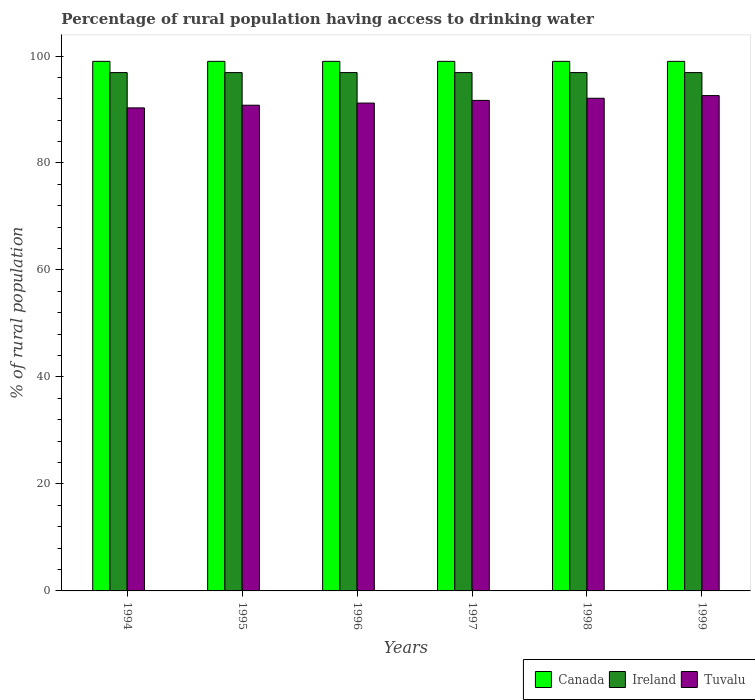How many groups of bars are there?
Offer a terse response. 6. How many bars are there on the 6th tick from the left?
Give a very brief answer. 3. What is the percentage of rural population having access to drinking water in Tuvalu in 1996?
Your answer should be very brief. 91.2. Across all years, what is the maximum percentage of rural population having access to drinking water in Ireland?
Ensure brevity in your answer.  96.9. Across all years, what is the minimum percentage of rural population having access to drinking water in Canada?
Keep it short and to the point. 99. In which year was the percentage of rural population having access to drinking water in Ireland maximum?
Your response must be concise. 1994. What is the total percentage of rural population having access to drinking water in Ireland in the graph?
Offer a very short reply. 581.4. What is the difference between the percentage of rural population having access to drinking water in Tuvalu in 1995 and that in 1997?
Your answer should be very brief. -0.9. What is the difference between the percentage of rural population having access to drinking water in Tuvalu in 1999 and the percentage of rural population having access to drinking water in Canada in 1995?
Offer a terse response. -6.4. In the year 1998, what is the difference between the percentage of rural population having access to drinking water in Tuvalu and percentage of rural population having access to drinking water in Ireland?
Provide a succinct answer. -4.8. In how many years, is the percentage of rural population having access to drinking water in Ireland greater than 48 %?
Your answer should be compact. 6. What is the ratio of the percentage of rural population having access to drinking water in Tuvalu in 1994 to that in 1999?
Ensure brevity in your answer.  0.98. What is the difference between the highest and the lowest percentage of rural population having access to drinking water in Tuvalu?
Your answer should be compact. 2.3. In how many years, is the percentage of rural population having access to drinking water in Ireland greater than the average percentage of rural population having access to drinking water in Ireland taken over all years?
Your answer should be very brief. 6. What does the 3rd bar from the left in 1994 represents?
Provide a short and direct response. Tuvalu. What does the 2nd bar from the right in 1994 represents?
Provide a succinct answer. Ireland. Is it the case that in every year, the sum of the percentage of rural population having access to drinking water in Tuvalu and percentage of rural population having access to drinking water in Ireland is greater than the percentage of rural population having access to drinking water in Canada?
Offer a very short reply. Yes. How many bars are there?
Offer a terse response. 18. Are all the bars in the graph horizontal?
Keep it short and to the point. No. What is the difference between two consecutive major ticks on the Y-axis?
Your answer should be compact. 20. Where does the legend appear in the graph?
Keep it short and to the point. Bottom right. How many legend labels are there?
Offer a terse response. 3. How are the legend labels stacked?
Keep it short and to the point. Horizontal. What is the title of the graph?
Your answer should be very brief. Percentage of rural population having access to drinking water. What is the label or title of the Y-axis?
Your response must be concise. % of rural population. What is the % of rural population of Ireland in 1994?
Provide a short and direct response. 96.9. What is the % of rural population in Tuvalu in 1994?
Your answer should be very brief. 90.3. What is the % of rural population in Canada in 1995?
Provide a succinct answer. 99. What is the % of rural population in Ireland in 1995?
Offer a terse response. 96.9. What is the % of rural population in Tuvalu in 1995?
Make the answer very short. 90.8. What is the % of rural population in Ireland in 1996?
Offer a terse response. 96.9. What is the % of rural population of Tuvalu in 1996?
Provide a succinct answer. 91.2. What is the % of rural population of Canada in 1997?
Your answer should be compact. 99. What is the % of rural population of Ireland in 1997?
Make the answer very short. 96.9. What is the % of rural population of Tuvalu in 1997?
Offer a very short reply. 91.7. What is the % of rural population of Ireland in 1998?
Offer a terse response. 96.9. What is the % of rural population in Tuvalu in 1998?
Offer a very short reply. 92.1. What is the % of rural population in Ireland in 1999?
Provide a succinct answer. 96.9. What is the % of rural population in Tuvalu in 1999?
Keep it short and to the point. 92.6. Across all years, what is the maximum % of rural population in Canada?
Ensure brevity in your answer.  99. Across all years, what is the maximum % of rural population of Ireland?
Offer a terse response. 96.9. Across all years, what is the maximum % of rural population in Tuvalu?
Keep it short and to the point. 92.6. Across all years, what is the minimum % of rural population in Ireland?
Make the answer very short. 96.9. Across all years, what is the minimum % of rural population of Tuvalu?
Provide a short and direct response. 90.3. What is the total % of rural population in Canada in the graph?
Keep it short and to the point. 594. What is the total % of rural population in Ireland in the graph?
Your answer should be very brief. 581.4. What is the total % of rural population of Tuvalu in the graph?
Ensure brevity in your answer.  548.7. What is the difference between the % of rural population in Ireland in 1994 and that in 1995?
Provide a succinct answer. 0. What is the difference between the % of rural population of Ireland in 1994 and that in 1996?
Ensure brevity in your answer.  0. What is the difference between the % of rural population in Canada in 1994 and that in 1997?
Your answer should be very brief. 0. What is the difference between the % of rural population in Ireland in 1994 and that in 1997?
Offer a very short reply. 0. What is the difference between the % of rural population in Canada in 1994 and that in 1998?
Ensure brevity in your answer.  0. What is the difference between the % of rural population of Tuvalu in 1994 and that in 1998?
Offer a terse response. -1.8. What is the difference between the % of rural population in Canada in 1994 and that in 1999?
Provide a short and direct response. 0. What is the difference between the % of rural population of Tuvalu in 1994 and that in 1999?
Your answer should be compact. -2.3. What is the difference between the % of rural population in Tuvalu in 1995 and that in 1996?
Offer a very short reply. -0.4. What is the difference between the % of rural population of Canada in 1995 and that in 1997?
Your answer should be very brief. 0. What is the difference between the % of rural population of Canada in 1995 and that in 1998?
Your answer should be compact. 0. What is the difference between the % of rural population in Ireland in 1995 and that in 1998?
Your response must be concise. 0. What is the difference between the % of rural population in Canada in 1995 and that in 1999?
Your answer should be compact. 0. What is the difference between the % of rural population in Tuvalu in 1995 and that in 1999?
Keep it short and to the point. -1.8. What is the difference between the % of rural population in Canada in 1996 and that in 1997?
Keep it short and to the point. 0. What is the difference between the % of rural population in Canada in 1996 and that in 1999?
Make the answer very short. 0. What is the difference between the % of rural population in Ireland in 1996 and that in 1999?
Your answer should be compact. 0. What is the difference between the % of rural population of Canada in 1997 and that in 1998?
Give a very brief answer. 0. What is the difference between the % of rural population in Ireland in 1997 and that in 1998?
Your response must be concise. 0. What is the difference between the % of rural population of Ireland in 1997 and that in 1999?
Provide a short and direct response. 0. What is the difference between the % of rural population of Tuvalu in 1997 and that in 1999?
Offer a terse response. -0.9. What is the difference between the % of rural population in Canada in 1998 and that in 1999?
Your response must be concise. 0. What is the difference between the % of rural population in Tuvalu in 1998 and that in 1999?
Keep it short and to the point. -0.5. What is the difference between the % of rural population in Canada in 1994 and the % of rural population in Ireland in 1995?
Provide a short and direct response. 2.1. What is the difference between the % of rural population in Canada in 1994 and the % of rural population in Tuvalu in 1995?
Your response must be concise. 8.2. What is the difference between the % of rural population of Canada in 1994 and the % of rural population of Ireland in 1996?
Make the answer very short. 2.1. What is the difference between the % of rural population in Canada in 1994 and the % of rural population in Tuvalu in 1996?
Your answer should be very brief. 7.8. What is the difference between the % of rural population of Ireland in 1994 and the % of rural population of Tuvalu in 1996?
Keep it short and to the point. 5.7. What is the difference between the % of rural population of Canada in 1994 and the % of rural population of Ireland in 1998?
Provide a short and direct response. 2.1. What is the difference between the % of rural population of Ireland in 1994 and the % of rural population of Tuvalu in 1998?
Ensure brevity in your answer.  4.8. What is the difference between the % of rural population of Ireland in 1994 and the % of rural population of Tuvalu in 1999?
Make the answer very short. 4.3. What is the difference between the % of rural population of Ireland in 1995 and the % of rural population of Tuvalu in 1996?
Give a very brief answer. 5.7. What is the difference between the % of rural population in Canada in 1995 and the % of rural population in Tuvalu in 1997?
Provide a succinct answer. 7.3. What is the difference between the % of rural population of Ireland in 1995 and the % of rural population of Tuvalu in 1997?
Offer a terse response. 5.2. What is the difference between the % of rural population of Ireland in 1995 and the % of rural population of Tuvalu in 1998?
Provide a short and direct response. 4.8. What is the difference between the % of rural population of Canada in 1995 and the % of rural population of Tuvalu in 1999?
Provide a succinct answer. 6.4. What is the difference between the % of rural population in Ireland in 1995 and the % of rural population in Tuvalu in 1999?
Offer a terse response. 4.3. What is the difference between the % of rural population in Canada in 1996 and the % of rural population in Tuvalu in 1997?
Provide a short and direct response. 7.3. What is the difference between the % of rural population of Ireland in 1996 and the % of rural population of Tuvalu in 1997?
Keep it short and to the point. 5.2. What is the difference between the % of rural population of Canada in 1996 and the % of rural population of Ireland in 1998?
Your answer should be very brief. 2.1. What is the difference between the % of rural population of Canada in 1996 and the % of rural population of Ireland in 1999?
Your answer should be very brief. 2.1. What is the difference between the % of rural population of Ireland in 1996 and the % of rural population of Tuvalu in 1999?
Your answer should be very brief. 4.3. What is the difference between the % of rural population in Ireland in 1997 and the % of rural population in Tuvalu in 1998?
Your answer should be compact. 4.8. What is the difference between the % of rural population of Canada in 1998 and the % of rural population of Ireland in 1999?
Your answer should be compact. 2.1. What is the average % of rural population in Canada per year?
Your response must be concise. 99. What is the average % of rural population of Ireland per year?
Your answer should be very brief. 96.9. What is the average % of rural population in Tuvalu per year?
Your answer should be very brief. 91.45. In the year 1994, what is the difference between the % of rural population of Canada and % of rural population of Tuvalu?
Provide a short and direct response. 8.7. In the year 1995, what is the difference between the % of rural population of Canada and % of rural population of Ireland?
Provide a short and direct response. 2.1. In the year 1996, what is the difference between the % of rural population in Ireland and % of rural population in Tuvalu?
Provide a succinct answer. 5.7. In the year 1997, what is the difference between the % of rural population in Ireland and % of rural population in Tuvalu?
Your answer should be very brief. 5.2. In the year 1998, what is the difference between the % of rural population in Canada and % of rural population in Ireland?
Keep it short and to the point. 2.1. In the year 1998, what is the difference between the % of rural population in Canada and % of rural population in Tuvalu?
Your answer should be very brief. 6.9. In the year 1998, what is the difference between the % of rural population of Ireland and % of rural population of Tuvalu?
Your response must be concise. 4.8. In the year 1999, what is the difference between the % of rural population in Canada and % of rural population in Ireland?
Your answer should be very brief. 2.1. In the year 1999, what is the difference between the % of rural population in Ireland and % of rural population in Tuvalu?
Your answer should be compact. 4.3. What is the ratio of the % of rural population of Ireland in 1994 to that in 1995?
Provide a short and direct response. 1. What is the ratio of the % of rural population of Ireland in 1994 to that in 1996?
Offer a very short reply. 1. What is the ratio of the % of rural population of Ireland in 1994 to that in 1997?
Keep it short and to the point. 1. What is the ratio of the % of rural population in Tuvalu in 1994 to that in 1997?
Your answer should be very brief. 0.98. What is the ratio of the % of rural population in Ireland in 1994 to that in 1998?
Provide a short and direct response. 1. What is the ratio of the % of rural population of Tuvalu in 1994 to that in 1998?
Your response must be concise. 0.98. What is the ratio of the % of rural population in Ireland in 1994 to that in 1999?
Offer a terse response. 1. What is the ratio of the % of rural population of Tuvalu in 1994 to that in 1999?
Ensure brevity in your answer.  0.98. What is the ratio of the % of rural population in Canada in 1995 to that in 1996?
Your answer should be compact. 1. What is the ratio of the % of rural population in Ireland in 1995 to that in 1996?
Offer a terse response. 1. What is the ratio of the % of rural population of Tuvalu in 1995 to that in 1997?
Your answer should be very brief. 0.99. What is the ratio of the % of rural population of Ireland in 1995 to that in 1998?
Provide a short and direct response. 1. What is the ratio of the % of rural population in Tuvalu in 1995 to that in 1998?
Your response must be concise. 0.99. What is the ratio of the % of rural population in Canada in 1995 to that in 1999?
Provide a short and direct response. 1. What is the ratio of the % of rural population of Tuvalu in 1995 to that in 1999?
Your response must be concise. 0.98. What is the ratio of the % of rural population in Ireland in 1996 to that in 1997?
Give a very brief answer. 1. What is the ratio of the % of rural population of Tuvalu in 1996 to that in 1997?
Provide a succinct answer. 0.99. What is the ratio of the % of rural population in Ireland in 1996 to that in 1998?
Make the answer very short. 1. What is the ratio of the % of rural population of Tuvalu in 1996 to that in 1998?
Offer a terse response. 0.99. What is the ratio of the % of rural population of Canada in 1996 to that in 1999?
Your response must be concise. 1. What is the ratio of the % of rural population of Ireland in 1996 to that in 1999?
Ensure brevity in your answer.  1. What is the ratio of the % of rural population of Tuvalu in 1996 to that in 1999?
Provide a succinct answer. 0.98. What is the ratio of the % of rural population in Canada in 1997 to that in 1998?
Offer a very short reply. 1. What is the ratio of the % of rural population of Ireland in 1997 to that in 1999?
Your answer should be compact. 1. What is the ratio of the % of rural population in Tuvalu in 1997 to that in 1999?
Provide a succinct answer. 0.99. What is the difference between the highest and the second highest % of rural population in Canada?
Give a very brief answer. 0. What is the difference between the highest and the second highest % of rural population of Tuvalu?
Your response must be concise. 0.5. What is the difference between the highest and the lowest % of rural population of Ireland?
Your answer should be very brief. 0. What is the difference between the highest and the lowest % of rural population in Tuvalu?
Provide a succinct answer. 2.3. 